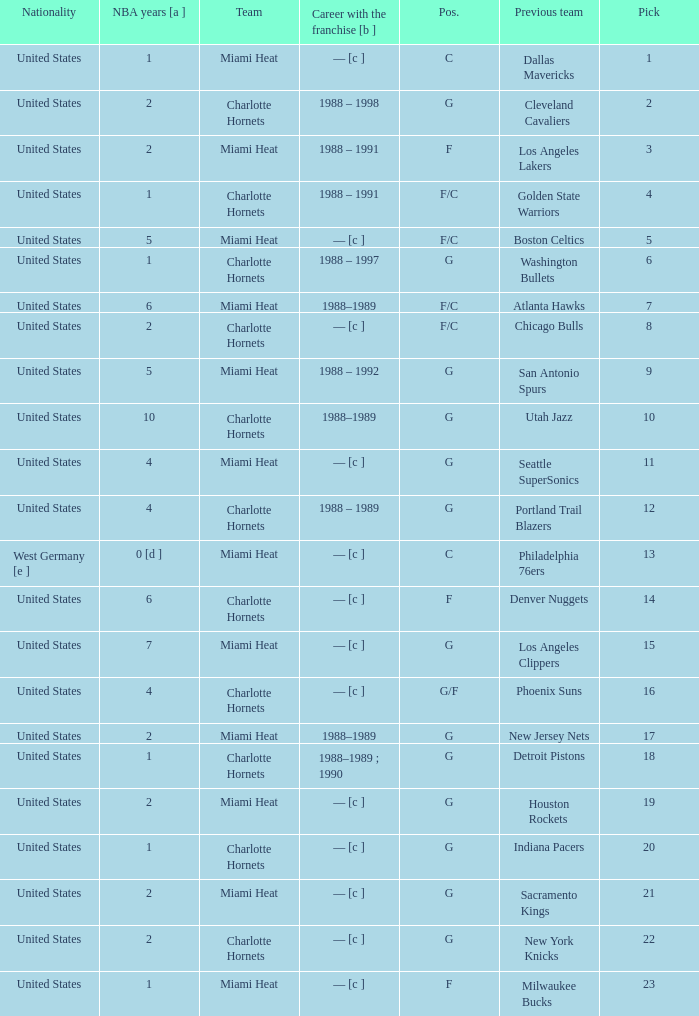What is the team of the player who was previously on the indiana pacers? Charlotte Hornets. 